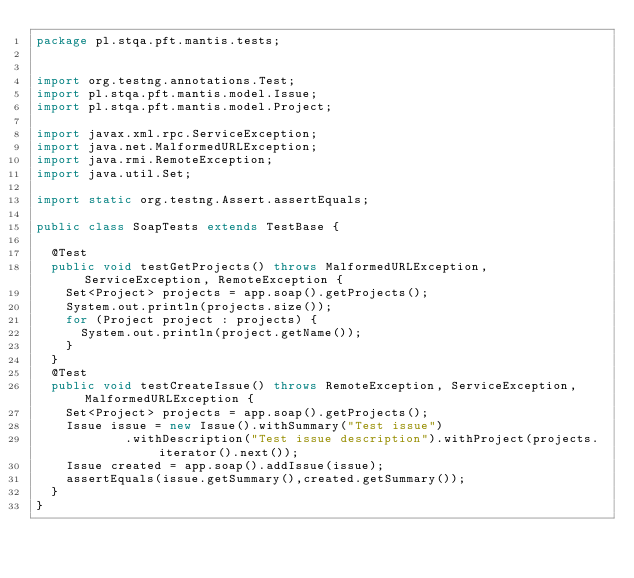Convert code to text. <code><loc_0><loc_0><loc_500><loc_500><_Java_>package pl.stqa.pft.mantis.tests;


import org.testng.annotations.Test;
import pl.stqa.pft.mantis.model.Issue;
import pl.stqa.pft.mantis.model.Project;

import javax.xml.rpc.ServiceException;
import java.net.MalformedURLException;
import java.rmi.RemoteException;
import java.util.Set;

import static org.testng.Assert.assertEquals;

public class SoapTests extends TestBase {

  @Test
  public void testGetProjects() throws MalformedURLException, ServiceException, RemoteException {
    Set<Project> projects = app.soap().getProjects();
    System.out.println(projects.size());
    for (Project project : projects) {
      System.out.println(project.getName());
    }
  }
  @Test
  public void testCreateIssue() throws RemoteException, ServiceException, MalformedURLException {
    Set<Project> projects = app.soap().getProjects();
    Issue issue = new Issue().withSummary("Test issue")
            .withDescription("Test issue description").withProject(projects.iterator().next());
    Issue created = app.soap().addIssue(issue);
    assertEquals(issue.getSummary(),created.getSummary());
  }
}

</code> 